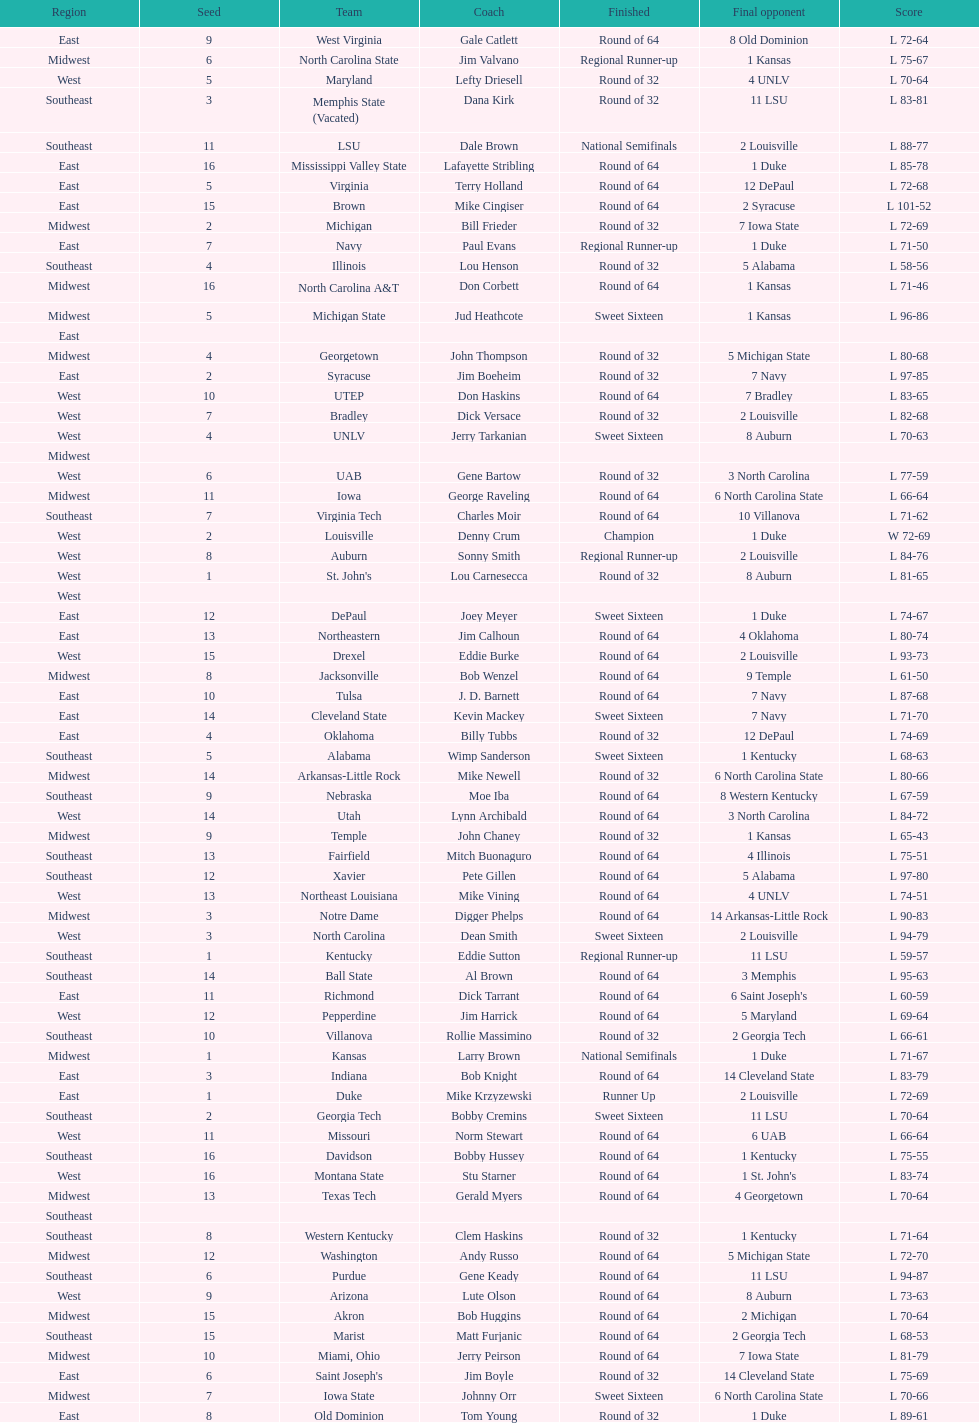North carolina and unlv each made it to which round? Sweet Sixteen. 